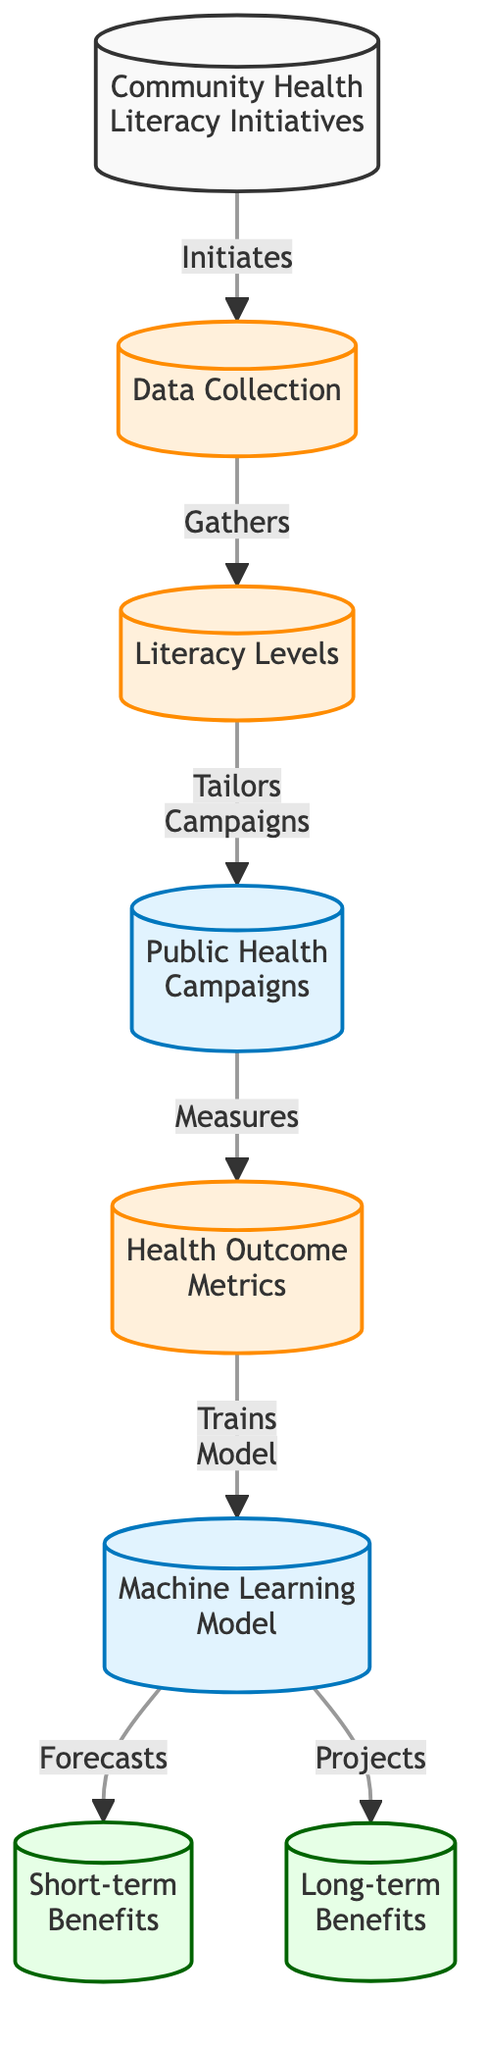What is the first step in the diagram? The diagram indicates that the first step is "Community Health Literacy Initiatives," which initiates the overall process. This is represented as the first node in the flowchart.
Answer: Community Health Literacy Initiatives How many types of benefits are projected in the diagram? The diagram shows two types of benefits: "Short-term Benefits" and "Long-term Benefits." These are represented as outcome nodes connected to the machine learning model.
Answer: Two What does the data collected represent? The diagram defines "Data Collection" as the step that gathers information about "Literacy Levels." Thus, the data collected reflects the literacy levels within the community.
Answer: Literacy Levels Which node measures health outcome metrics? The diagram shows that the "Public Health Campaigns" node measures the "Health Outcome Metrics." This relationship is indicated by the direct flow from campaigns to outcome metrics.
Answer: Health Outcome Metrics How does the machine learning model forecast benefits? The machine learning model forecasts "Short-term Benefits" and projects "Long-term Benefits." It performs these functions based on the input data from health outcome metrics.
Answer: Short-term Benefits and Long-term Benefits What step precedes the training of the machine learning model? Prior to the training of the machine learning model, "Health Outcome Metrics" must be measured. This is indicated by the direct flow from the metrics node to the model node.
Answer: Health Outcome Metrics Which node represents the output of the machine learning model? The outputs of the machine learning model are represented as "Short-term Benefits" and "Long-term Benefits." These outcomes flow from the machine learning model node.
Answer: Short-term Benefits and Long-term Benefits What does community health literacy inititate? The community health literacy initiatives initiate the "Data Collection" process. This is clearly indicated by the directed flow from the first node to the data collection node.
Answer: Data Collection What is the purpose of tailoring public health campaigns? The purpose of tailoring public health campaigns is to cater to different "Literacy Levels." This customization is crucial for evaluating the effectiveness of the campaigns based on varied literacy within the community.
Answer: Tailors Campaigns 